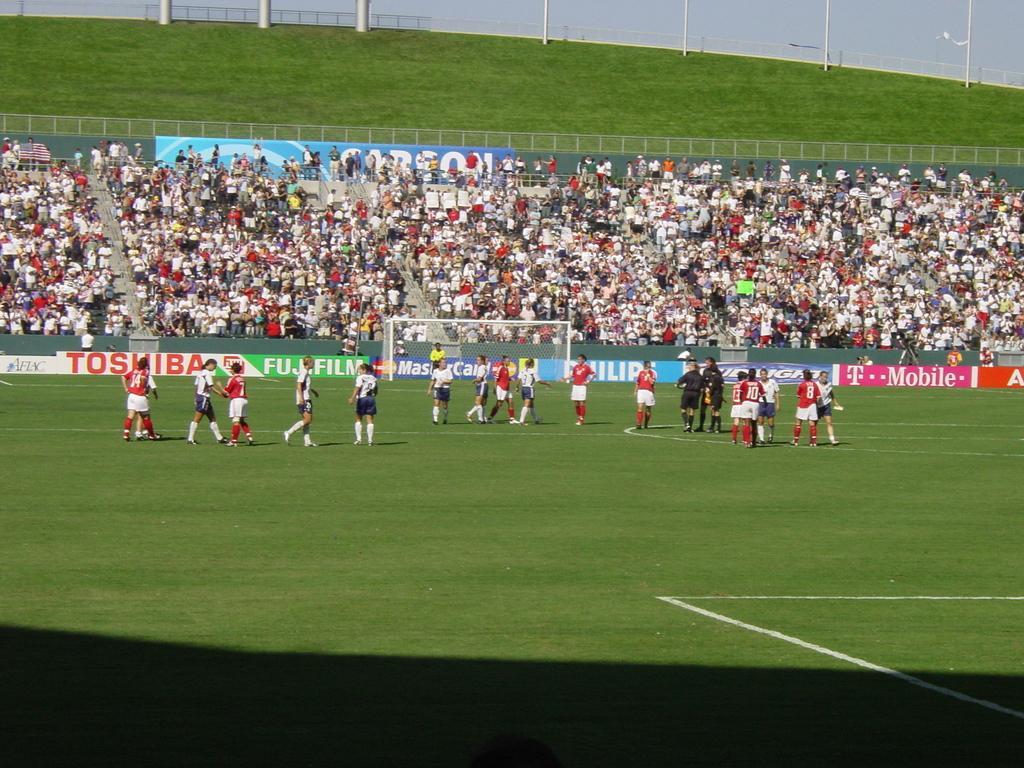Describe this image in one or two sentences. In this image I can see people standing in a ground. There is a goal court in the center. There is grass, fence and poles at the back. 